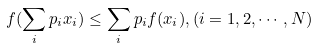Convert formula to latex. <formula><loc_0><loc_0><loc_500><loc_500>f ( \sum _ { i } p _ { i } x _ { i } ) \leq \sum _ { i } p _ { i } f ( x _ { i } ) , ( i = 1 , 2 , \cdots , N )</formula> 